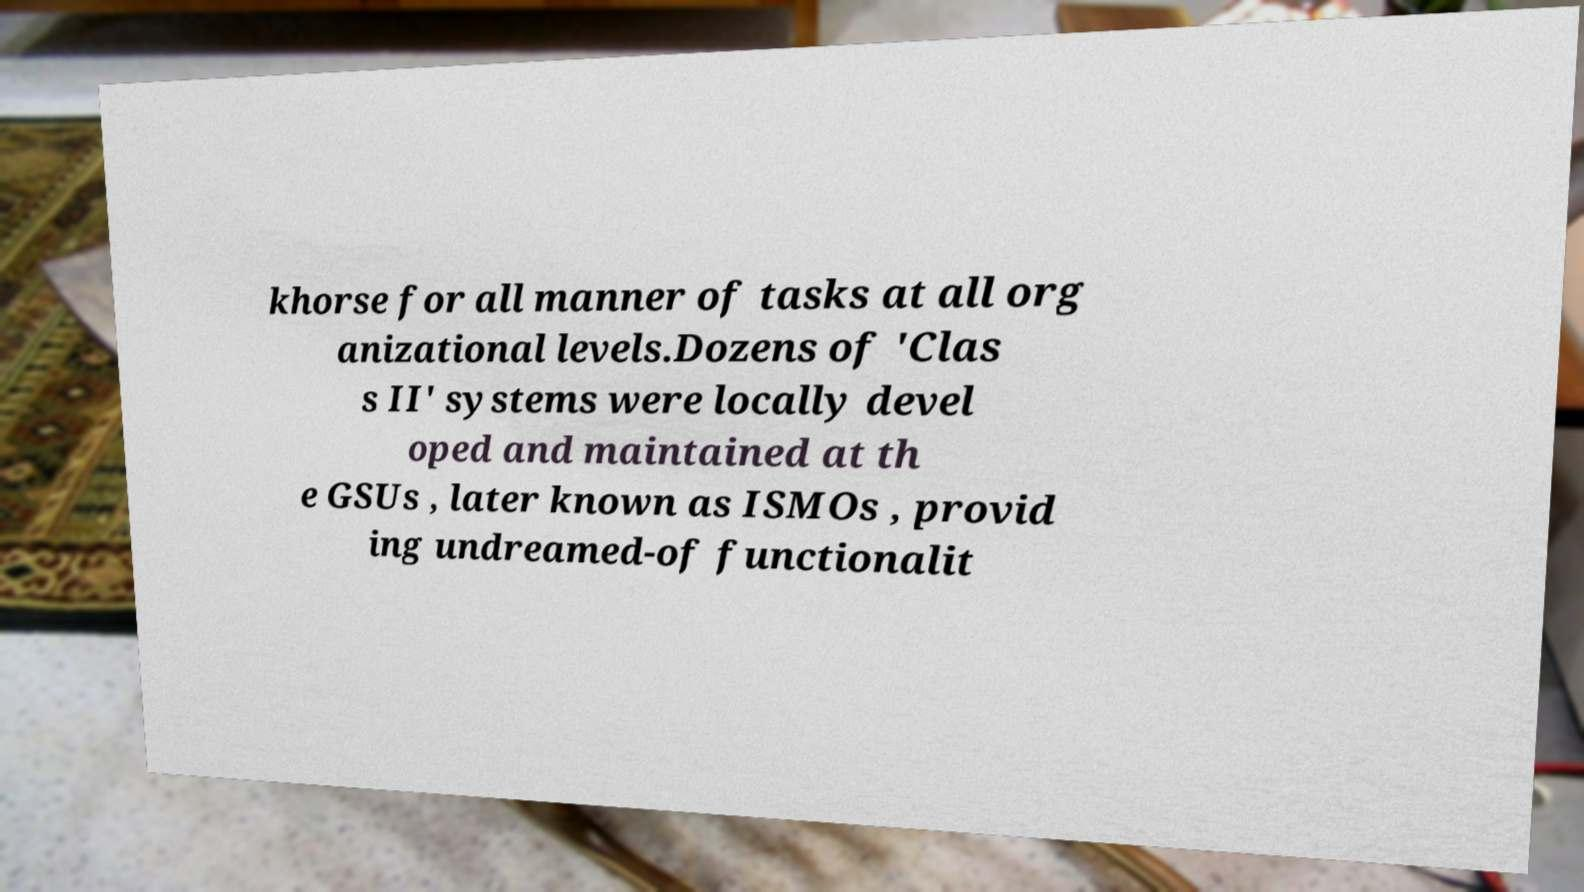Could you extract and type out the text from this image? khorse for all manner of tasks at all org anizational levels.Dozens of 'Clas s II' systems were locally devel oped and maintained at th e GSUs , later known as ISMOs , provid ing undreamed-of functionalit 